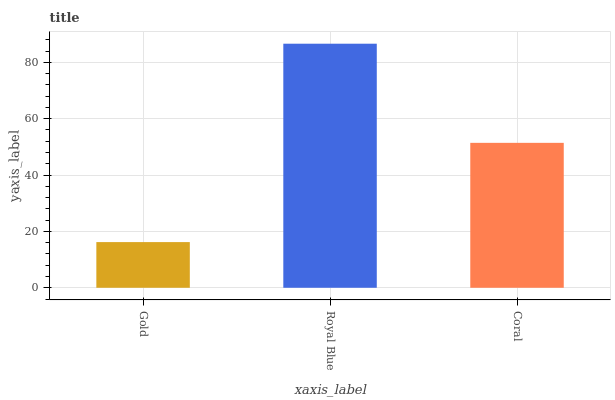Is Coral the minimum?
Answer yes or no. No. Is Coral the maximum?
Answer yes or no. No. Is Royal Blue greater than Coral?
Answer yes or no. Yes. Is Coral less than Royal Blue?
Answer yes or no. Yes. Is Coral greater than Royal Blue?
Answer yes or no. No. Is Royal Blue less than Coral?
Answer yes or no. No. Is Coral the high median?
Answer yes or no. Yes. Is Coral the low median?
Answer yes or no. Yes. Is Gold the high median?
Answer yes or no. No. Is Royal Blue the low median?
Answer yes or no. No. 